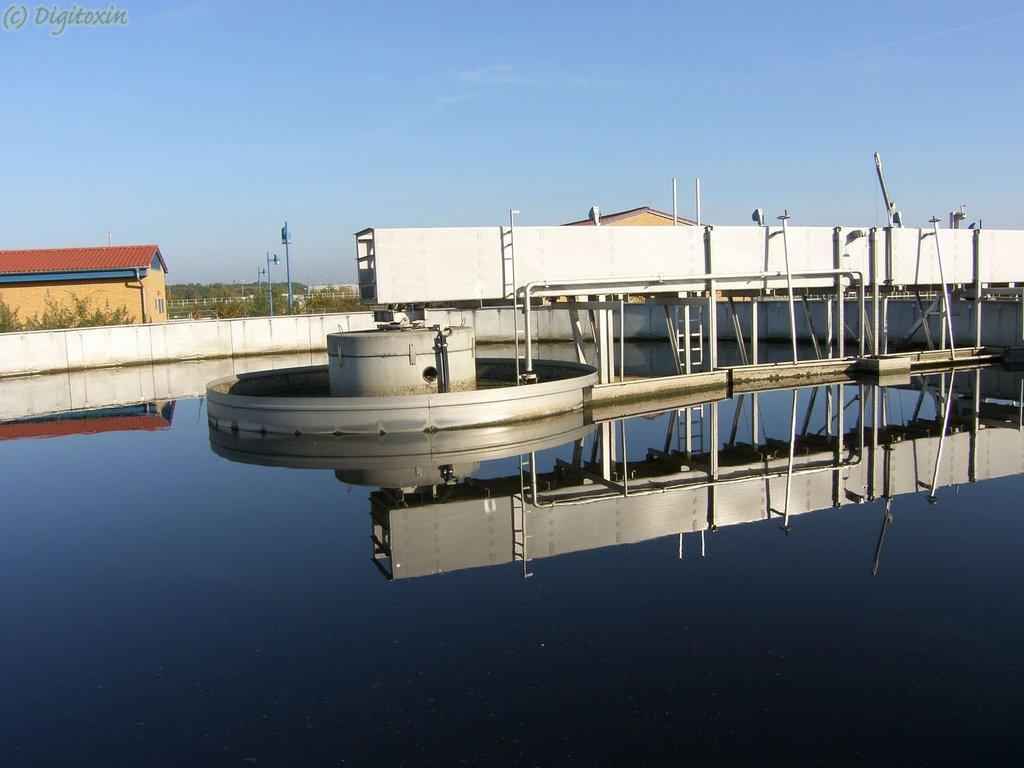What is located in the center of the image? There is water in the center of the image. What other object can be seen in the image? There is a machine in the image. What can be seen in the background of the image? There is a house and trees in the background of the image. What is visible at the top of the image? The sky is visible at the top of the image. Can you tell me how many receipts are floating in the water in the image? There are no receipts present in the image; it features water in the center. Are there any cats visible in the image? There are no cats present in the image. 